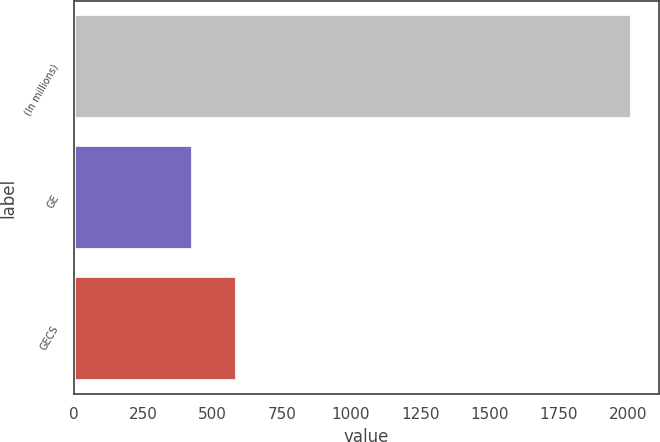<chart> <loc_0><loc_0><loc_500><loc_500><bar_chart><fcel>(In millions)<fcel>GE<fcel>GECS<nl><fcel>2012<fcel>429<fcel>587.3<nl></chart> 